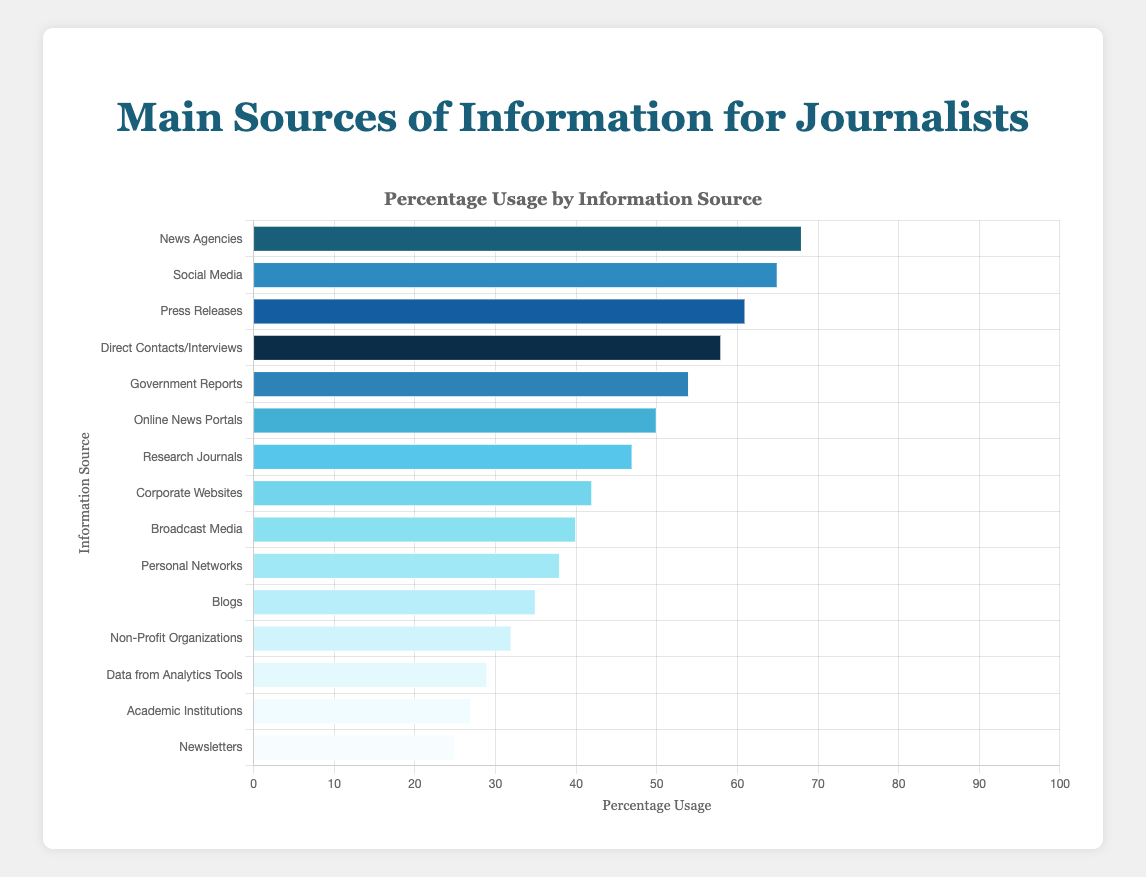Which source has the highest percentage usage? The source with the highest percentage usage can be determined by identifying the bar with the greatest length. According to the figure, "News Agencies" has the longest bar with a usage percentage of 68%.
Answer: News Agencies Which source has the lowest percentage usage? The source with the lowest percentage usage can be determined by identifying the bar with the shortest length. According to the figure, "Newsletters" has the shortest bar with a usage percentage of 25%.
Answer: Newsletters What is the difference in percentage usage between "Social Media" and "Corporate Websites"? To find this difference, subtract the percentage usage of "Corporate Websites" from that of "Social Media". "Social Media" has a usage of 65%, and "Corporate Websites" has a usage of 42%. 65 - 42 = 23
Answer: 23 Which sources have a usage percentage higher than 50%? To determine which sources have a usage percentage higher than 50%, look for bars that extend beyond the 50% mark. The sources are "News Agencies" (68%), "Social Media" (65%), "Press Releases" (61%), "Direct Contacts/Interviews" (58%), and "Government Reports" (54%).
Answer: News Agencies, Social Media, Press Releases, Direct Contacts/Interviews, Government Reports What is the average percentage usage of the top three sources? To find the average, sum the percentage usage of the top three sources and divide by 3. The top three sources are "News Agencies" (68%), "Social Media" (65%), and "Press Releases" (61%). The sum is 68 + 65 + 61 = 194. Then, 194 / 3 ≈ 64.67
Answer: 64.67 How many sources have a percentage usage between 30% and 50%? To find this number, count the sources whose bars extend within the 30% and 50% range. These sources are "Online News Portals" (50%), "Research Journals" (47%), "Corporate Websites" (42%), "Broadcast Media" (40%), "Personal Networks" (38%), and "Blogs" (35%). There are six sources.
Answer: 6 Which sources have nearly the same percentage usage as "Online News Portals"? Find the sources whose usage percentage is close to 50%, similar to "Online News Portals". "Research Journals" have a usage of 47%, which is nearest to 50%.
Answer: Research Journals What is the sum of the percentage usages for "Government Reports" and "Data from Analytics Tools"? To find the sum, add the percentage usage of "Government Reports" (54%) and "Data from Analytics Tools" (29%). 54 + 29 = 83
Answer: 83 What is the median value of the percentage usages of all the sources? To find the median, first list all percentage usages in ascending order: 25, 27, 29, 32, 35, 38, 40, 42, 47, 50, 54, 58, 61, 65, 68. Since there are 15 values, the median is the 8th value in the ordered list, which is 42.
Answer: 42 